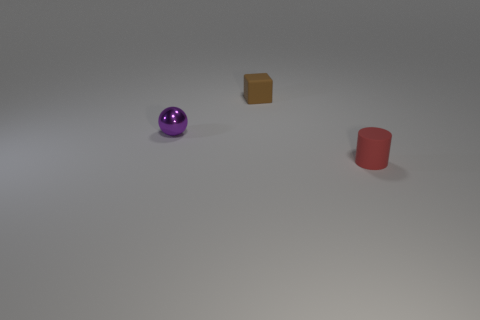What number of purple objects are either cubes or small objects?
Provide a short and direct response. 1. What number of tiny metallic things are to the right of the ball?
Give a very brief answer. 0. Is the number of small gray cylinders greater than the number of small red rubber cylinders?
Offer a very short reply. No. The thing right of the tiny thing behind the purple shiny thing is what shape?
Make the answer very short. Cylinder. Does the shiny object have the same color as the small cylinder?
Provide a succinct answer. No. Is the number of tiny spheres that are right of the purple metal ball greater than the number of tiny rubber cubes?
Offer a terse response. No. There is a tiny object that is behind the small purple thing; how many objects are left of it?
Your answer should be compact. 1. Does the small thing that is to the right of the small brown block have the same material as the small block that is right of the purple ball?
Your answer should be compact. Yes. What number of tiny red matte objects are the same shape as the brown matte object?
Provide a short and direct response. 0. Is the material of the purple ball the same as the small object that is in front of the small metal object?
Give a very brief answer. No. 